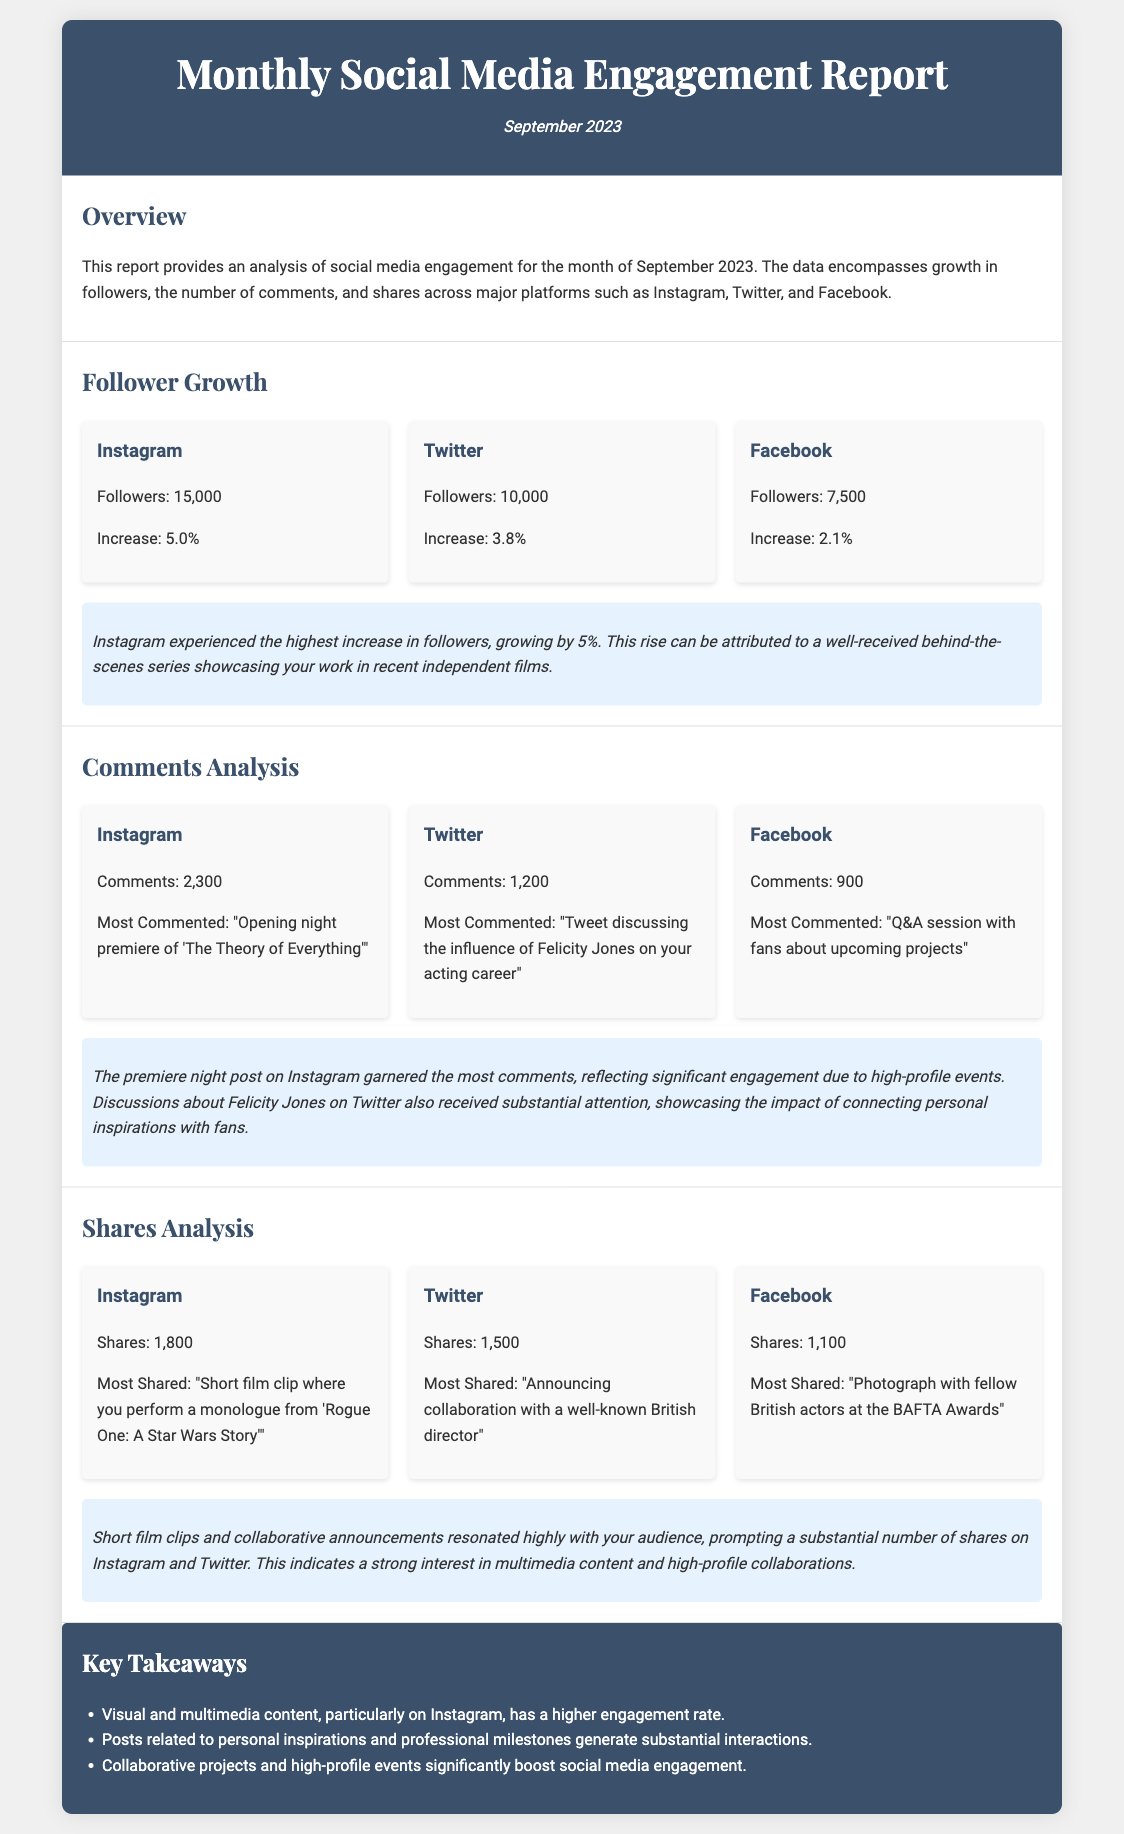What was the follower count on Instagram? The document states the follower count for Instagram is 15,000.
Answer: 15,000 Which platform had the highest percentage increase in followers? According to the report, Instagram had the highest increase at 5.0%.
Answer: Instagram What was the most commented post on Twitter? The report indicates the most commented post on Twitter was about Felicity Jones' influence.
Answer: Tweet discussing the influence of Felicity Jones on your acting career How many shares did the most shared Instagram post receive? The document mentions that the most shared Instagram post received 1,800 shares.
Answer: 1,800 What is the total number of comments across all platforms? The total number of comments is calculated as 2,300 (Instagram) + 1,200 (Twitter) + 900 (Facebook) = 4,400.
Answer: 4,400 What type of content resulted in higher engagement rates? The key takeaways highlight that visual and multimedia content had a higher engagement rate.
Answer: Visual and multimedia content What event led to significant Instagram comments? The post about the opening night premiere of 'The Theory of Everything' received significant comments.
Answer: Opening night premiere of 'The Theory of Everything' What type of post prompted many shares on Twitter? The indication is that announcing collaboration with a director prompted many shares on Twitter.
Answer: Announcing collaboration with a well-known British director 